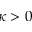Convert formula to latex. <formula><loc_0><loc_0><loc_500><loc_500>\kappa > 0</formula> 